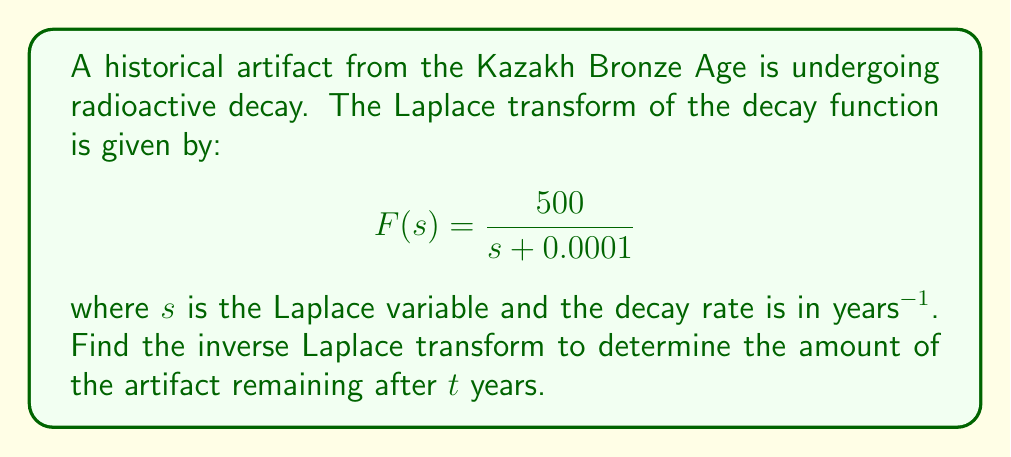Help me with this question. To find the inverse Laplace transform, we need to recognize the standard form of this transform. The given function is in the form:

$$F(s) = \frac{A}{s + a}$$

where $A = 500$ and $a = 0.0001$.

The inverse Laplace transform of this form is:

$$f(t) = A e^{-at}$$

Therefore, substituting our values:

$$f(t) = 500 e^{-0.0001t}$$

This function represents the amount of the artifact remaining after $t$ years. The initial amount (at $t = 0$) is 500 units, and it decays exponentially with a rate constant of 0.0001 year^(-1).

The slow decay rate (0.0001 year^(-1)) indicates that this artifact is decaying very slowly, which is typical for many archaeological finds. This slow decay allows archaeologists and museum curators to preserve and study artifacts over long periods.
Answer: $f(t) = 500 e^{-0.0001t}$ 